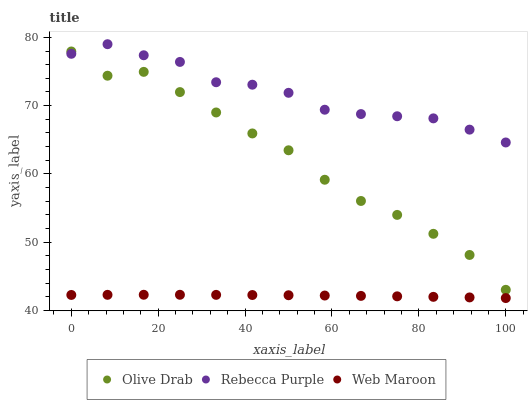Does Web Maroon have the minimum area under the curve?
Answer yes or no. Yes. Does Rebecca Purple have the maximum area under the curve?
Answer yes or no. Yes. Does Olive Drab have the minimum area under the curve?
Answer yes or no. No. Does Olive Drab have the maximum area under the curve?
Answer yes or no. No. Is Web Maroon the smoothest?
Answer yes or no. Yes. Is Olive Drab the roughest?
Answer yes or no. Yes. Is Rebecca Purple the smoothest?
Answer yes or no. No. Is Rebecca Purple the roughest?
Answer yes or no. No. Does Web Maroon have the lowest value?
Answer yes or no. Yes. Does Olive Drab have the lowest value?
Answer yes or no. No. Does Rebecca Purple have the highest value?
Answer yes or no. Yes. Does Olive Drab have the highest value?
Answer yes or no. No. Is Web Maroon less than Rebecca Purple?
Answer yes or no. Yes. Is Rebecca Purple greater than Web Maroon?
Answer yes or no. Yes. Does Olive Drab intersect Rebecca Purple?
Answer yes or no. Yes. Is Olive Drab less than Rebecca Purple?
Answer yes or no. No. Is Olive Drab greater than Rebecca Purple?
Answer yes or no. No. Does Web Maroon intersect Rebecca Purple?
Answer yes or no. No. 